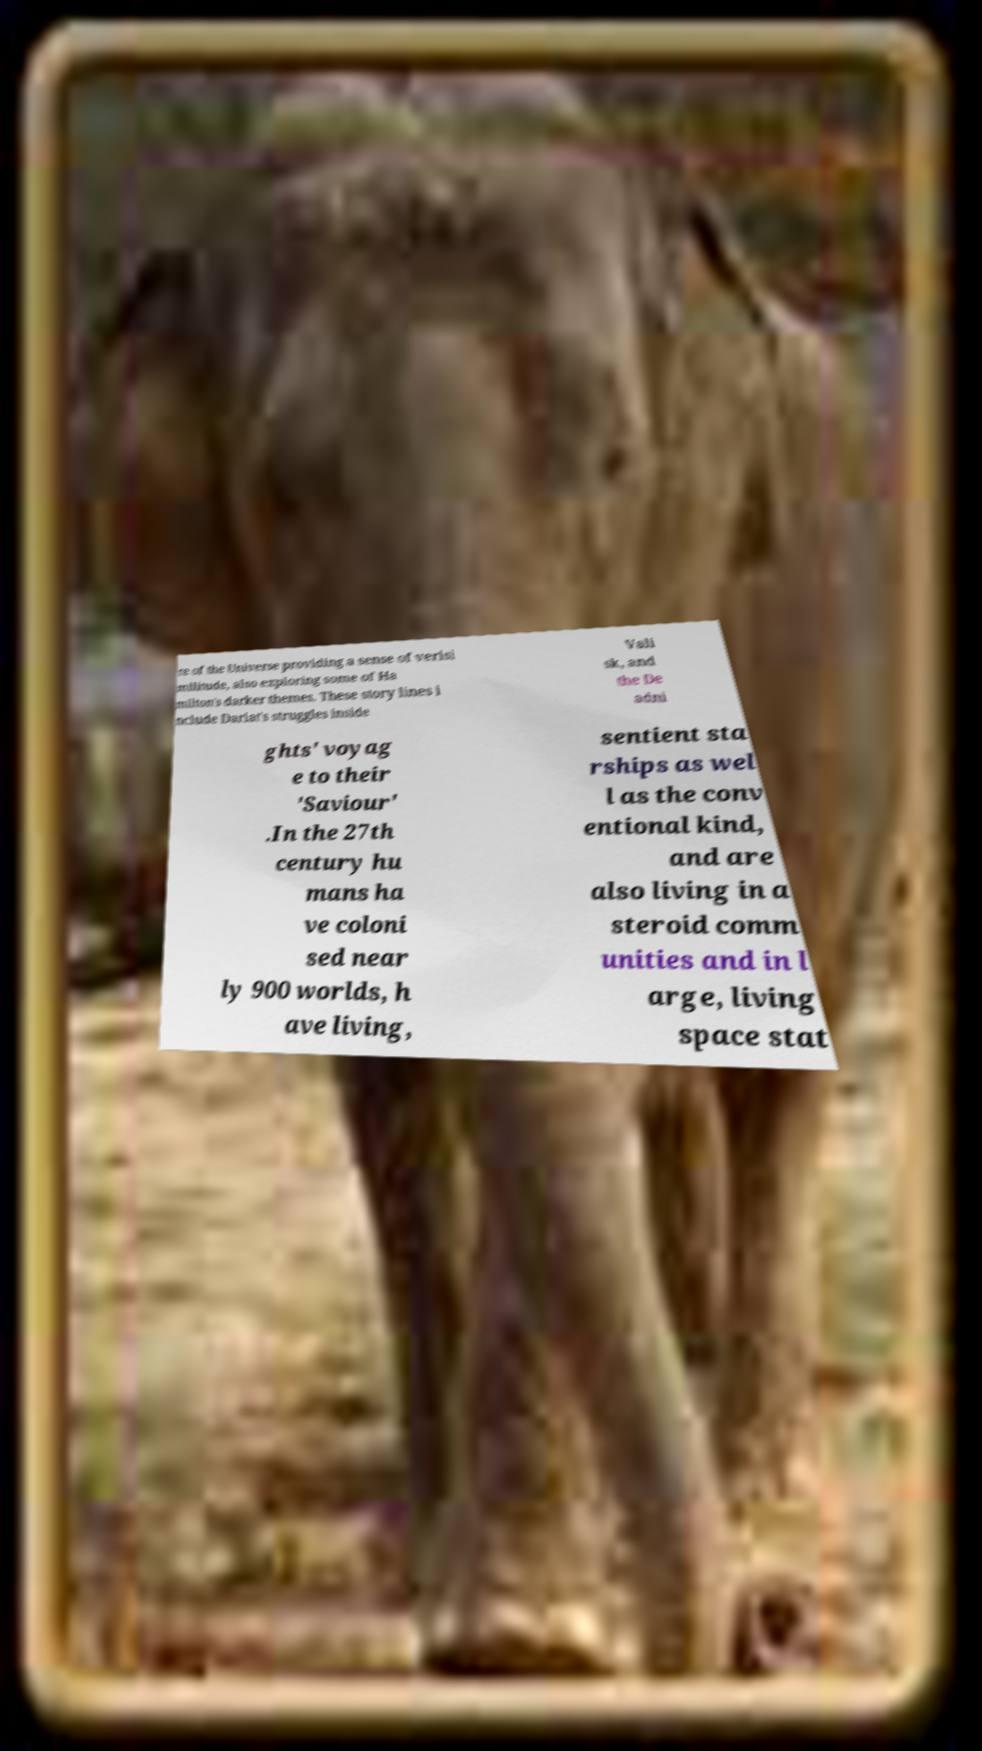I need the written content from this picture converted into text. Can you do that? re of the Universe providing a sense of verisi militude, also exploring some of Ha milton's darker themes. These story lines i nclude Dariat's struggles inside Vali sk, and the De adni ghts' voyag e to their 'Saviour' .In the 27th century hu mans ha ve coloni sed near ly 900 worlds, h ave living, sentient sta rships as wel l as the conv entional kind, and are also living in a steroid comm unities and in l arge, living space stat 